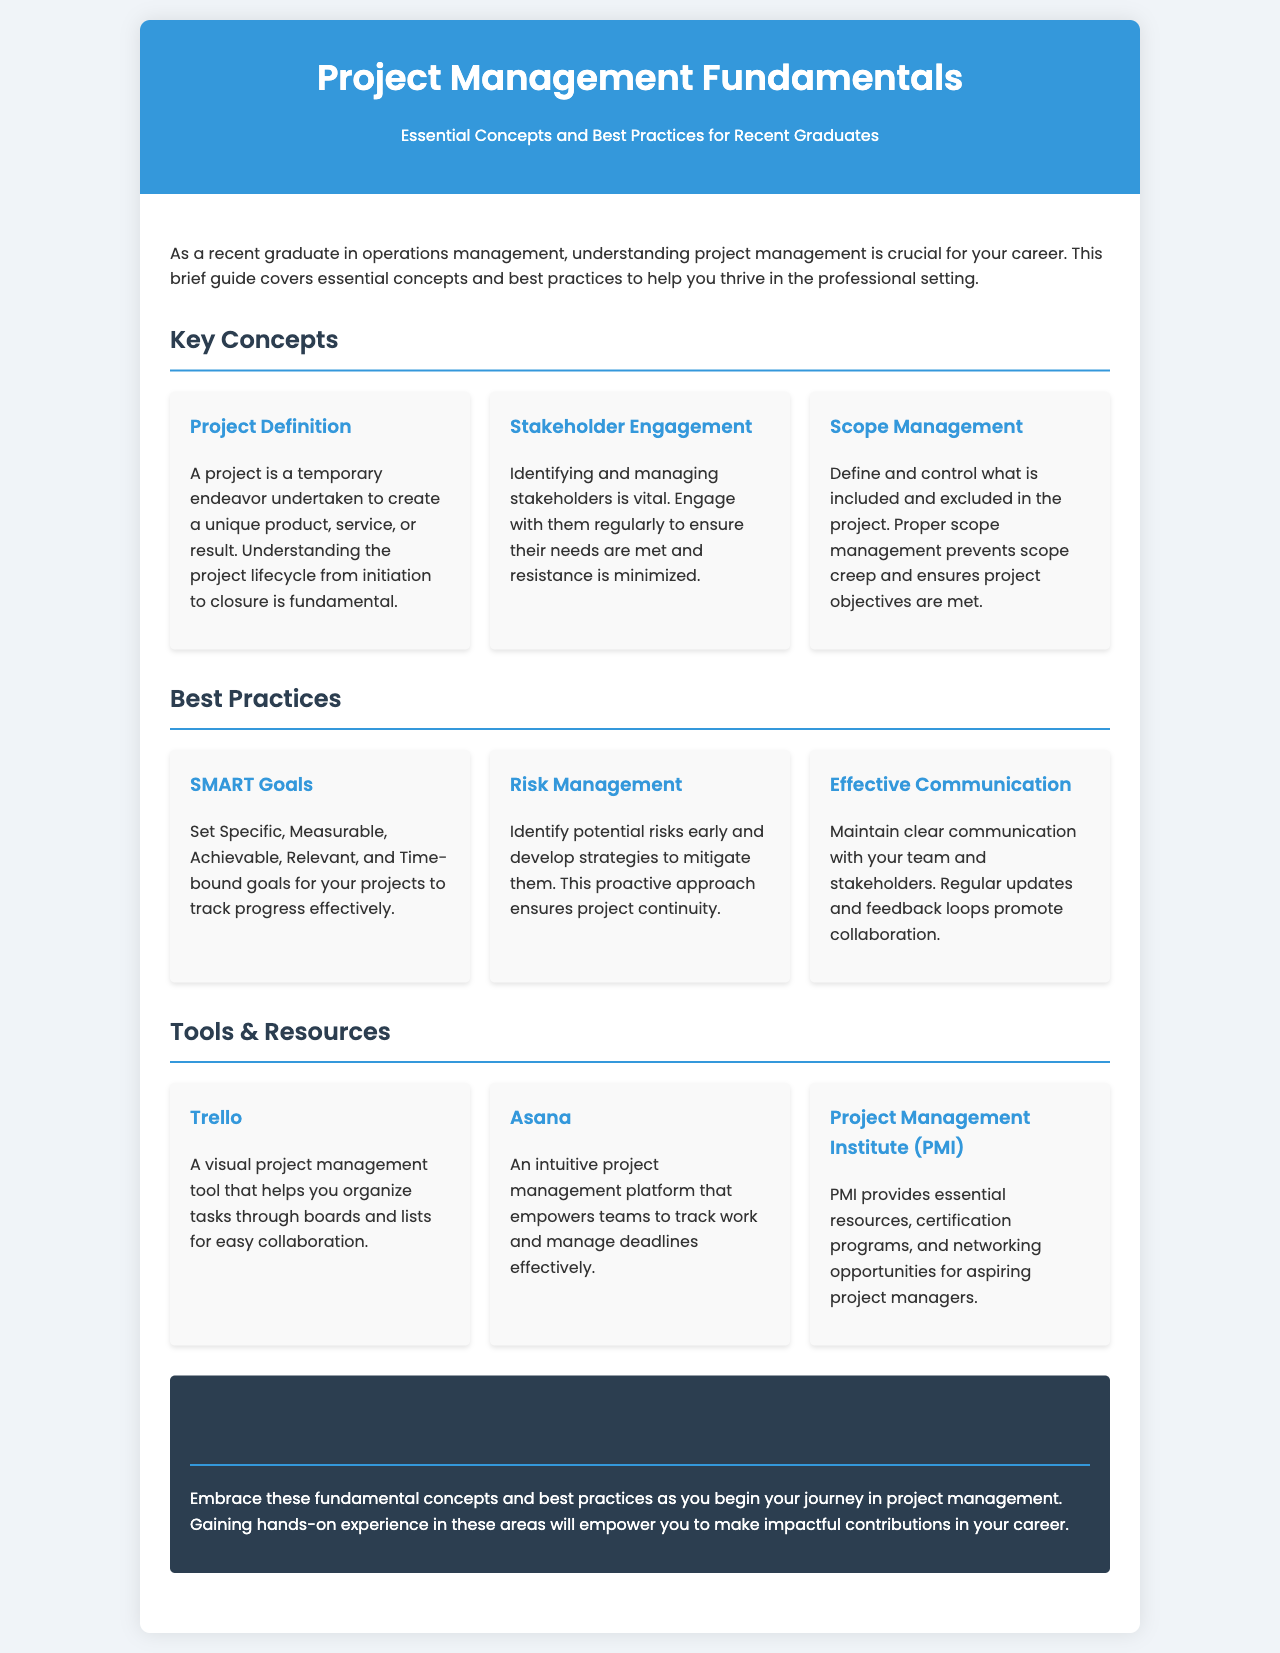What is the title of the brochure? The title is prominently displayed at the top of the document in the header section.
Answer: Project Management Fundamentals What is the main focus of the brochure? The brochure is designed to provide guidance for recent graduates in their new professional roles, as indicated in the introduction.
Answer: Essential Concepts and Best Practices for Recent Graduates Name one key concept mentioned in the brochure. The document lists several key concepts under the "Key Concepts" section, each highlighted in a separate card.
Answer: Project Definition What does SMART stand for in project management? The term SMART is defined in the "Best Practices" section as a guideline for setting goals, and each letter represents a specific criterion.
Answer: Specific, Measurable, Achievable, Relevant, Time-bound Which project management tool is described as visual? This tool is highlighted in the "Tools & Resources" section and describes its function in organizing tasks.
Answer: Trello What is one recommendation for effective communication in project management? The brochure emphasizes the importance of maintaining clear communication with the team and stakeholders as a best practice.
Answer: Regular updates and feedback loops How many key concepts are listed in the brochure? The document includes three key concepts under the "Key Concepts" section.
Answer: Three What organization provides networking opportunities for aspiring project managers? This organization is mentioned in the "Tools & Resources" section and is known for its relevant resources and certification programs.
Answer: Project Management Institute (PMI) What is the color scheme of the header section? The brochure uses a specific set of colors for the header to create a visual impact and maintain consistency throughout the document.
Answer: Blue and white 